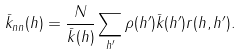<formula> <loc_0><loc_0><loc_500><loc_500>\bar { k } _ { n n } ( h ) = \frac { N } { \bar { k } ( h ) } \sum _ { h ^ { \prime } } \rho ( h ^ { \prime } ) \bar { k } ( h ^ { \prime } ) r ( h , h ^ { \prime } ) .</formula> 